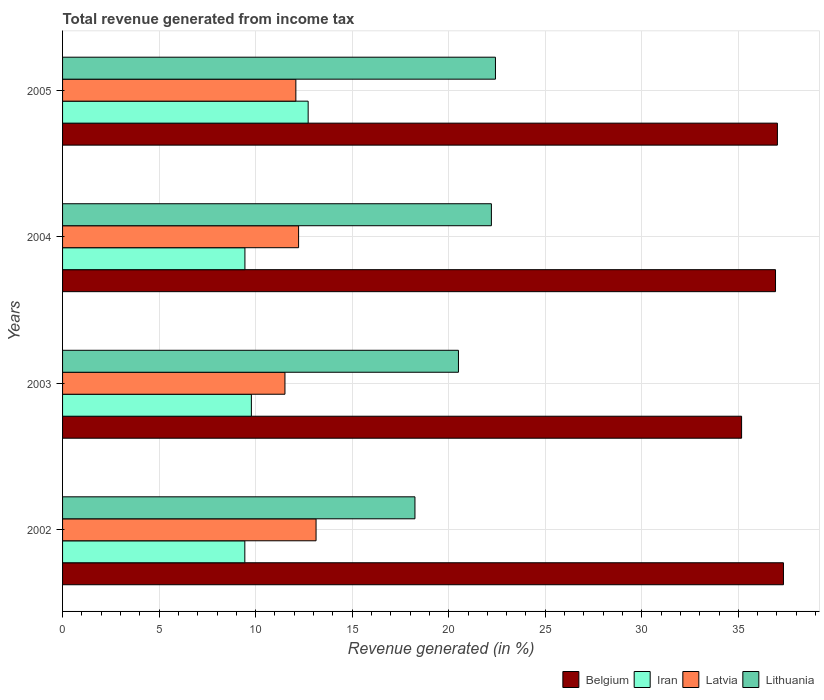How many groups of bars are there?
Give a very brief answer. 4. Are the number of bars per tick equal to the number of legend labels?
Provide a succinct answer. Yes. How many bars are there on the 3rd tick from the top?
Provide a succinct answer. 4. How many bars are there on the 4th tick from the bottom?
Provide a short and direct response. 4. In how many cases, is the number of bars for a given year not equal to the number of legend labels?
Keep it short and to the point. 0. What is the total revenue generated in Lithuania in 2004?
Your response must be concise. 22.21. Across all years, what is the maximum total revenue generated in Iran?
Offer a very short reply. 12.72. Across all years, what is the minimum total revenue generated in Iran?
Provide a succinct answer. 9.44. In which year was the total revenue generated in Latvia maximum?
Keep it short and to the point. 2002. In which year was the total revenue generated in Latvia minimum?
Keep it short and to the point. 2003. What is the total total revenue generated in Latvia in the graph?
Offer a very short reply. 48.96. What is the difference between the total revenue generated in Latvia in 2002 and that in 2005?
Your response must be concise. 1.05. What is the difference between the total revenue generated in Lithuania in 2005 and the total revenue generated in Belgium in 2002?
Ensure brevity in your answer.  -14.92. What is the average total revenue generated in Latvia per year?
Provide a succinct answer. 12.24. In the year 2004, what is the difference between the total revenue generated in Iran and total revenue generated in Latvia?
Keep it short and to the point. -2.78. What is the ratio of the total revenue generated in Iran in 2002 to that in 2005?
Keep it short and to the point. 0.74. Is the difference between the total revenue generated in Iran in 2004 and 2005 greater than the difference between the total revenue generated in Latvia in 2004 and 2005?
Provide a succinct answer. No. What is the difference between the highest and the second highest total revenue generated in Latvia?
Your answer should be compact. 0.9. What is the difference between the highest and the lowest total revenue generated in Belgium?
Offer a terse response. 2.17. What does the 1st bar from the top in 2004 represents?
Keep it short and to the point. Lithuania. What does the 4th bar from the bottom in 2003 represents?
Provide a short and direct response. Lithuania. Is it the case that in every year, the sum of the total revenue generated in Belgium and total revenue generated in Lithuania is greater than the total revenue generated in Iran?
Keep it short and to the point. Yes. How many bars are there?
Make the answer very short. 16. Are all the bars in the graph horizontal?
Ensure brevity in your answer.  Yes. How many years are there in the graph?
Your answer should be compact. 4. What is the difference between two consecutive major ticks on the X-axis?
Your response must be concise. 5. Are the values on the major ticks of X-axis written in scientific E-notation?
Your response must be concise. No. Does the graph contain any zero values?
Offer a terse response. No. How many legend labels are there?
Your answer should be compact. 4. How are the legend labels stacked?
Your answer should be compact. Horizontal. What is the title of the graph?
Your answer should be very brief. Total revenue generated from income tax. Does "Yemen, Rep." appear as one of the legend labels in the graph?
Offer a terse response. No. What is the label or title of the X-axis?
Keep it short and to the point. Revenue generated (in %). What is the Revenue generated (in %) in Belgium in 2002?
Your response must be concise. 37.34. What is the Revenue generated (in %) of Iran in 2002?
Keep it short and to the point. 9.44. What is the Revenue generated (in %) in Latvia in 2002?
Make the answer very short. 13.13. What is the Revenue generated (in %) of Lithuania in 2002?
Provide a succinct answer. 18.25. What is the Revenue generated (in %) in Belgium in 2003?
Give a very brief answer. 35.17. What is the Revenue generated (in %) of Iran in 2003?
Provide a succinct answer. 9.78. What is the Revenue generated (in %) of Latvia in 2003?
Your answer should be compact. 11.52. What is the Revenue generated (in %) in Lithuania in 2003?
Provide a succinct answer. 20.5. What is the Revenue generated (in %) in Belgium in 2004?
Your answer should be compact. 36.93. What is the Revenue generated (in %) in Iran in 2004?
Make the answer very short. 9.45. What is the Revenue generated (in %) of Latvia in 2004?
Offer a terse response. 12.22. What is the Revenue generated (in %) in Lithuania in 2004?
Provide a short and direct response. 22.21. What is the Revenue generated (in %) in Belgium in 2005?
Keep it short and to the point. 37.02. What is the Revenue generated (in %) in Iran in 2005?
Make the answer very short. 12.72. What is the Revenue generated (in %) of Latvia in 2005?
Ensure brevity in your answer.  12.08. What is the Revenue generated (in %) in Lithuania in 2005?
Make the answer very short. 22.42. Across all years, what is the maximum Revenue generated (in %) in Belgium?
Make the answer very short. 37.34. Across all years, what is the maximum Revenue generated (in %) in Iran?
Offer a very short reply. 12.72. Across all years, what is the maximum Revenue generated (in %) in Latvia?
Offer a terse response. 13.13. Across all years, what is the maximum Revenue generated (in %) of Lithuania?
Give a very brief answer. 22.42. Across all years, what is the minimum Revenue generated (in %) in Belgium?
Keep it short and to the point. 35.17. Across all years, what is the minimum Revenue generated (in %) in Iran?
Provide a short and direct response. 9.44. Across all years, what is the minimum Revenue generated (in %) in Latvia?
Keep it short and to the point. 11.52. Across all years, what is the minimum Revenue generated (in %) of Lithuania?
Ensure brevity in your answer.  18.25. What is the total Revenue generated (in %) in Belgium in the graph?
Keep it short and to the point. 146.46. What is the total Revenue generated (in %) in Iran in the graph?
Your answer should be compact. 41.38. What is the total Revenue generated (in %) in Latvia in the graph?
Your answer should be compact. 48.96. What is the total Revenue generated (in %) of Lithuania in the graph?
Offer a very short reply. 83.39. What is the difference between the Revenue generated (in %) of Belgium in 2002 and that in 2003?
Your answer should be compact. 2.17. What is the difference between the Revenue generated (in %) in Iran in 2002 and that in 2003?
Your response must be concise. -0.34. What is the difference between the Revenue generated (in %) in Latvia in 2002 and that in 2003?
Make the answer very short. 1.61. What is the difference between the Revenue generated (in %) in Lithuania in 2002 and that in 2003?
Provide a succinct answer. -2.25. What is the difference between the Revenue generated (in %) of Belgium in 2002 and that in 2004?
Offer a terse response. 0.41. What is the difference between the Revenue generated (in %) in Iran in 2002 and that in 2004?
Provide a short and direct response. -0.01. What is the difference between the Revenue generated (in %) of Latvia in 2002 and that in 2004?
Give a very brief answer. 0.9. What is the difference between the Revenue generated (in %) of Lithuania in 2002 and that in 2004?
Provide a short and direct response. -3.96. What is the difference between the Revenue generated (in %) of Belgium in 2002 and that in 2005?
Offer a terse response. 0.31. What is the difference between the Revenue generated (in %) of Iran in 2002 and that in 2005?
Keep it short and to the point. -3.28. What is the difference between the Revenue generated (in %) of Latvia in 2002 and that in 2005?
Provide a short and direct response. 1.05. What is the difference between the Revenue generated (in %) in Lithuania in 2002 and that in 2005?
Make the answer very short. -4.17. What is the difference between the Revenue generated (in %) of Belgium in 2003 and that in 2004?
Offer a very short reply. -1.76. What is the difference between the Revenue generated (in %) of Iran in 2003 and that in 2004?
Offer a very short reply. 0.33. What is the difference between the Revenue generated (in %) of Latvia in 2003 and that in 2004?
Your response must be concise. -0.71. What is the difference between the Revenue generated (in %) of Lithuania in 2003 and that in 2004?
Provide a short and direct response. -1.71. What is the difference between the Revenue generated (in %) of Belgium in 2003 and that in 2005?
Your answer should be very brief. -1.85. What is the difference between the Revenue generated (in %) of Iran in 2003 and that in 2005?
Your response must be concise. -2.94. What is the difference between the Revenue generated (in %) in Latvia in 2003 and that in 2005?
Keep it short and to the point. -0.57. What is the difference between the Revenue generated (in %) of Lithuania in 2003 and that in 2005?
Your answer should be compact. -1.92. What is the difference between the Revenue generated (in %) in Belgium in 2004 and that in 2005?
Your response must be concise. -0.1. What is the difference between the Revenue generated (in %) in Iran in 2004 and that in 2005?
Your response must be concise. -3.27. What is the difference between the Revenue generated (in %) of Latvia in 2004 and that in 2005?
Provide a short and direct response. 0.14. What is the difference between the Revenue generated (in %) in Lithuania in 2004 and that in 2005?
Make the answer very short. -0.21. What is the difference between the Revenue generated (in %) in Belgium in 2002 and the Revenue generated (in %) in Iran in 2003?
Your answer should be very brief. 27.56. What is the difference between the Revenue generated (in %) in Belgium in 2002 and the Revenue generated (in %) in Latvia in 2003?
Ensure brevity in your answer.  25.82. What is the difference between the Revenue generated (in %) of Belgium in 2002 and the Revenue generated (in %) of Lithuania in 2003?
Keep it short and to the point. 16.83. What is the difference between the Revenue generated (in %) of Iran in 2002 and the Revenue generated (in %) of Latvia in 2003?
Ensure brevity in your answer.  -2.08. What is the difference between the Revenue generated (in %) of Iran in 2002 and the Revenue generated (in %) of Lithuania in 2003?
Offer a very short reply. -11.06. What is the difference between the Revenue generated (in %) in Latvia in 2002 and the Revenue generated (in %) in Lithuania in 2003?
Your answer should be compact. -7.38. What is the difference between the Revenue generated (in %) in Belgium in 2002 and the Revenue generated (in %) in Iran in 2004?
Your response must be concise. 27.89. What is the difference between the Revenue generated (in %) of Belgium in 2002 and the Revenue generated (in %) of Latvia in 2004?
Offer a very short reply. 25.11. What is the difference between the Revenue generated (in %) of Belgium in 2002 and the Revenue generated (in %) of Lithuania in 2004?
Keep it short and to the point. 15.13. What is the difference between the Revenue generated (in %) of Iran in 2002 and the Revenue generated (in %) of Latvia in 2004?
Keep it short and to the point. -2.78. What is the difference between the Revenue generated (in %) in Iran in 2002 and the Revenue generated (in %) in Lithuania in 2004?
Give a very brief answer. -12.77. What is the difference between the Revenue generated (in %) in Latvia in 2002 and the Revenue generated (in %) in Lithuania in 2004?
Your response must be concise. -9.08. What is the difference between the Revenue generated (in %) of Belgium in 2002 and the Revenue generated (in %) of Iran in 2005?
Offer a terse response. 24.62. What is the difference between the Revenue generated (in %) of Belgium in 2002 and the Revenue generated (in %) of Latvia in 2005?
Keep it short and to the point. 25.25. What is the difference between the Revenue generated (in %) in Belgium in 2002 and the Revenue generated (in %) in Lithuania in 2005?
Your answer should be compact. 14.92. What is the difference between the Revenue generated (in %) of Iran in 2002 and the Revenue generated (in %) of Latvia in 2005?
Offer a very short reply. -2.64. What is the difference between the Revenue generated (in %) in Iran in 2002 and the Revenue generated (in %) in Lithuania in 2005?
Give a very brief answer. -12.98. What is the difference between the Revenue generated (in %) of Latvia in 2002 and the Revenue generated (in %) of Lithuania in 2005?
Offer a very short reply. -9.29. What is the difference between the Revenue generated (in %) in Belgium in 2003 and the Revenue generated (in %) in Iran in 2004?
Provide a short and direct response. 25.72. What is the difference between the Revenue generated (in %) of Belgium in 2003 and the Revenue generated (in %) of Latvia in 2004?
Your answer should be very brief. 22.95. What is the difference between the Revenue generated (in %) of Belgium in 2003 and the Revenue generated (in %) of Lithuania in 2004?
Your response must be concise. 12.96. What is the difference between the Revenue generated (in %) in Iran in 2003 and the Revenue generated (in %) in Latvia in 2004?
Offer a very short reply. -2.45. What is the difference between the Revenue generated (in %) of Iran in 2003 and the Revenue generated (in %) of Lithuania in 2004?
Offer a very short reply. -12.43. What is the difference between the Revenue generated (in %) in Latvia in 2003 and the Revenue generated (in %) in Lithuania in 2004?
Give a very brief answer. -10.69. What is the difference between the Revenue generated (in %) in Belgium in 2003 and the Revenue generated (in %) in Iran in 2005?
Provide a succinct answer. 22.45. What is the difference between the Revenue generated (in %) of Belgium in 2003 and the Revenue generated (in %) of Latvia in 2005?
Offer a very short reply. 23.09. What is the difference between the Revenue generated (in %) in Belgium in 2003 and the Revenue generated (in %) in Lithuania in 2005?
Offer a very short reply. 12.75. What is the difference between the Revenue generated (in %) of Iran in 2003 and the Revenue generated (in %) of Latvia in 2005?
Your response must be concise. -2.3. What is the difference between the Revenue generated (in %) in Iran in 2003 and the Revenue generated (in %) in Lithuania in 2005?
Your answer should be very brief. -12.64. What is the difference between the Revenue generated (in %) of Latvia in 2003 and the Revenue generated (in %) of Lithuania in 2005?
Ensure brevity in your answer.  -10.9. What is the difference between the Revenue generated (in %) of Belgium in 2004 and the Revenue generated (in %) of Iran in 2005?
Your answer should be compact. 24.21. What is the difference between the Revenue generated (in %) of Belgium in 2004 and the Revenue generated (in %) of Latvia in 2005?
Offer a terse response. 24.84. What is the difference between the Revenue generated (in %) in Belgium in 2004 and the Revenue generated (in %) in Lithuania in 2005?
Give a very brief answer. 14.51. What is the difference between the Revenue generated (in %) in Iran in 2004 and the Revenue generated (in %) in Latvia in 2005?
Provide a succinct answer. -2.64. What is the difference between the Revenue generated (in %) of Iran in 2004 and the Revenue generated (in %) of Lithuania in 2005?
Ensure brevity in your answer.  -12.98. What is the difference between the Revenue generated (in %) of Latvia in 2004 and the Revenue generated (in %) of Lithuania in 2005?
Keep it short and to the point. -10.2. What is the average Revenue generated (in %) of Belgium per year?
Your answer should be compact. 36.61. What is the average Revenue generated (in %) in Iran per year?
Provide a succinct answer. 10.35. What is the average Revenue generated (in %) in Latvia per year?
Your response must be concise. 12.24. What is the average Revenue generated (in %) of Lithuania per year?
Provide a short and direct response. 20.85. In the year 2002, what is the difference between the Revenue generated (in %) in Belgium and Revenue generated (in %) in Iran?
Give a very brief answer. 27.9. In the year 2002, what is the difference between the Revenue generated (in %) in Belgium and Revenue generated (in %) in Latvia?
Give a very brief answer. 24.21. In the year 2002, what is the difference between the Revenue generated (in %) in Belgium and Revenue generated (in %) in Lithuania?
Your answer should be compact. 19.09. In the year 2002, what is the difference between the Revenue generated (in %) in Iran and Revenue generated (in %) in Latvia?
Ensure brevity in your answer.  -3.69. In the year 2002, what is the difference between the Revenue generated (in %) in Iran and Revenue generated (in %) in Lithuania?
Keep it short and to the point. -8.81. In the year 2002, what is the difference between the Revenue generated (in %) of Latvia and Revenue generated (in %) of Lithuania?
Your answer should be compact. -5.12. In the year 2003, what is the difference between the Revenue generated (in %) of Belgium and Revenue generated (in %) of Iran?
Give a very brief answer. 25.39. In the year 2003, what is the difference between the Revenue generated (in %) of Belgium and Revenue generated (in %) of Latvia?
Give a very brief answer. 23.65. In the year 2003, what is the difference between the Revenue generated (in %) of Belgium and Revenue generated (in %) of Lithuania?
Make the answer very short. 14.67. In the year 2003, what is the difference between the Revenue generated (in %) of Iran and Revenue generated (in %) of Latvia?
Provide a short and direct response. -1.74. In the year 2003, what is the difference between the Revenue generated (in %) of Iran and Revenue generated (in %) of Lithuania?
Keep it short and to the point. -10.73. In the year 2003, what is the difference between the Revenue generated (in %) in Latvia and Revenue generated (in %) in Lithuania?
Make the answer very short. -8.99. In the year 2004, what is the difference between the Revenue generated (in %) in Belgium and Revenue generated (in %) in Iran?
Give a very brief answer. 27.48. In the year 2004, what is the difference between the Revenue generated (in %) in Belgium and Revenue generated (in %) in Latvia?
Make the answer very short. 24.7. In the year 2004, what is the difference between the Revenue generated (in %) of Belgium and Revenue generated (in %) of Lithuania?
Your answer should be very brief. 14.72. In the year 2004, what is the difference between the Revenue generated (in %) in Iran and Revenue generated (in %) in Latvia?
Your answer should be compact. -2.78. In the year 2004, what is the difference between the Revenue generated (in %) in Iran and Revenue generated (in %) in Lithuania?
Provide a succinct answer. -12.77. In the year 2004, what is the difference between the Revenue generated (in %) of Latvia and Revenue generated (in %) of Lithuania?
Keep it short and to the point. -9.99. In the year 2005, what is the difference between the Revenue generated (in %) of Belgium and Revenue generated (in %) of Iran?
Provide a succinct answer. 24.3. In the year 2005, what is the difference between the Revenue generated (in %) of Belgium and Revenue generated (in %) of Latvia?
Your answer should be compact. 24.94. In the year 2005, what is the difference between the Revenue generated (in %) in Belgium and Revenue generated (in %) in Lithuania?
Your answer should be compact. 14.6. In the year 2005, what is the difference between the Revenue generated (in %) in Iran and Revenue generated (in %) in Latvia?
Provide a short and direct response. 0.64. In the year 2005, what is the difference between the Revenue generated (in %) of Iran and Revenue generated (in %) of Lithuania?
Give a very brief answer. -9.7. In the year 2005, what is the difference between the Revenue generated (in %) of Latvia and Revenue generated (in %) of Lithuania?
Your answer should be compact. -10.34. What is the ratio of the Revenue generated (in %) in Belgium in 2002 to that in 2003?
Make the answer very short. 1.06. What is the ratio of the Revenue generated (in %) of Iran in 2002 to that in 2003?
Your answer should be very brief. 0.97. What is the ratio of the Revenue generated (in %) of Latvia in 2002 to that in 2003?
Provide a short and direct response. 1.14. What is the ratio of the Revenue generated (in %) of Lithuania in 2002 to that in 2003?
Make the answer very short. 0.89. What is the ratio of the Revenue generated (in %) of Belgium in 2002 to that in 2004?
Your response must be concise. 1.01. What is the ratio of the Revenue generated (in %) of Iran in 2002 to that in 2004?
Provide a short and direct response. 1. What is the ratio of the Revenue generated (in %) of Latvia in 2002 to that in 2004?
Provide a short and direct response. 1.07. What is the ratio of the Revenue generated (in %) in Lithuania in 2002 to that in 2004?
Offer a terse response. 0.82. What is the ratio of the Revenue generated (in %) of Belgium in 2002 to that in 2005?
Give a very brief answer. 1.01. What is the ratio of the Revenue generated (in %) in Iran in 2002 to that in 2005?
Give a very brief answer. 0.74. What is the ratio of the Revenue generated (in %) in Latvia in 2002 to that in 2005?
Ensure brevity in your answer.  1.09. What is the ratio of the Revenue generated (in %) in Lithuania in 2002 to that in 2005?
Provide a succinct answer. 0.81. What is the ratio of the Revenue generated (in %) of Iran in 2003 to that in 2004?
Provide a short and direct response. 1.04. What is the ratio of the Revenue generated (in %) in Latvia in 2003 to that in 2004?
Give a very brief answer. 0.94. What is the ratio of the Revenue generated (in %) in Lithuania in 2003 to that in 2004?
Offer a terse response. 0.92. What is the ratio of the Revenue generated (in %) of Belgium in 2003 to that in 2005?
Your answer should be compact. 0.95. What is the ratio of the Revenue generated (in %) of Iran in 2003 to that in 2005?
Provide a succinct answer. 0.77. What is the ratio of the Revenue generated (in %) in Latvia in 2003 to that in 2005?
Offer a very short reply. 0.95. What is the ratio of the Revenue generated (in %) in Lithuania in 2003 to that in 2005?
Your response must be concise. 0.91. What is the ratio of the Revenue generated (in %) of Belgium in 2004 to that in 2005?
Give a very brief answer. 1. What is the ratio of the Revenue generated (in %) in Iran in 2004 to that in 2005?
Provide a succinct answer. 0.74. What is the ratio of the Revenue generated (in %) of Latvia in 2004 to that in 2005?
Your answer should be very brief. 1.01. What is the ratio of the Revenue generated (in %) in Lithuania in 2004 to that in 2005?
Ensure brevity in your answer.  0.99. What is the difference between the highest and the second highest Revenue generated (in %) of Belgium?
Your response must be concise. 0.31. What is the difference between the highest and the second highest Revenue generated (in %) in Iran?
Ensure brevity in your answer.  2.94. What is the difference between the highest and the second highest Revenue generated (in %) of Latvia?
Ensure brevity in your answer.  0.9. What is the difference between the highest and the second highest Revenue generated (in %) of Lithuania?
Provide a short and direct response. 0.21. What is the difference between the highest and the lowest Revenue generated (in %) of Belgium?
Offer a terse response. 2.17. What is the difference between the highest and the lowest Revenue generated (in %) of Iran?
Give a very brief answer. 3.28. What is the difference between the highest and the lowest Revenue generated (in %) in Latvia?
Provide a short and direct response. 1.61. What is the difference between the highest and the lowest Revenue generated (in %) in Lithuania?
Provide a succinct answer. 4.17. 